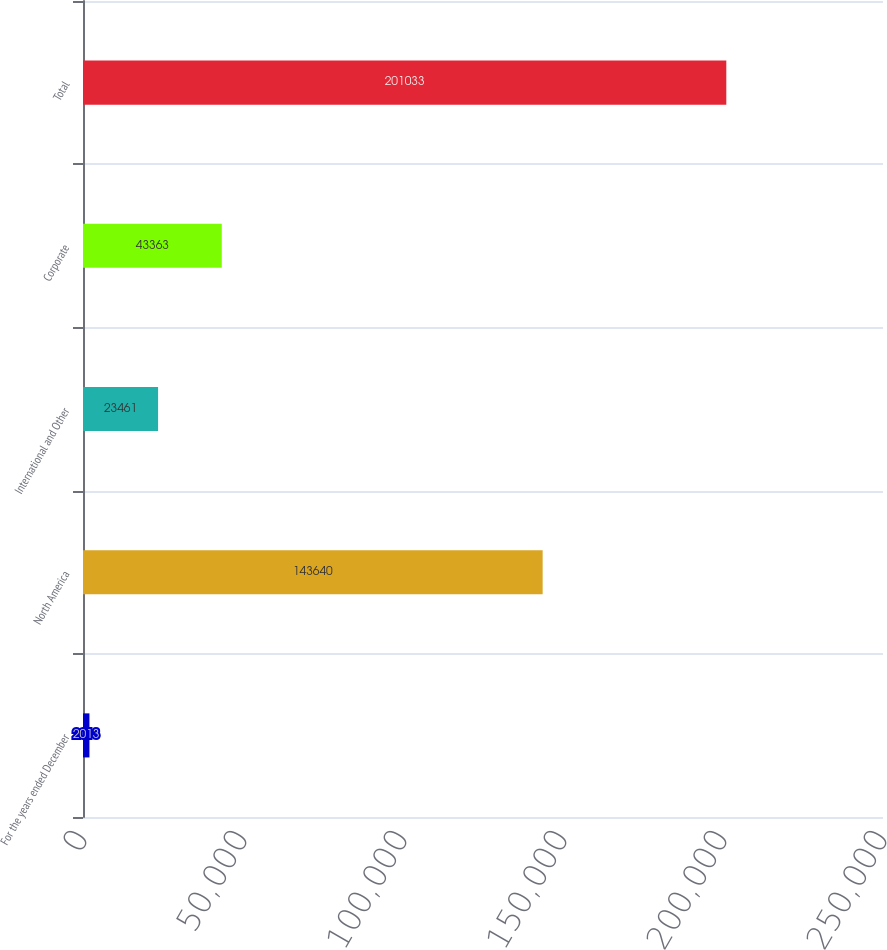Convert chart to OTSL. <chart><loc_0><loc_0><loc_500><loc_500><bar_chart><fcel>For the years ended December<fcel>North America<fcel>International and Other<fcel>Corporate<fcel>Total<nl><fcel>2013<fcel>143640<fcel>23461<fcel>43363<fcel>201033<nl></chart> 